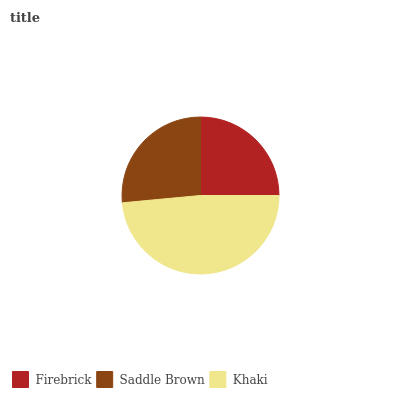Is Firebrick the minimum?
Answer yes or no. Yes. Is Khaki the maximum?
Answer yes or no. Yes. Is Saddle Brown the minimum?
Answer yes or no. No. Is Saddle Brown the maximum?
Answer yes or no. No. Is Saddle Brown greater than Firebrick?
Answer yes or no. Yes. Is Firebrick less than Saddle Brown?
Answer yes or no. Yes. Is Firebrick greater than Saddle Brown?
Answer yes or no. No. Is Saddle Brown less than Firebrick?
Answer yes or no. No. Is Saddle Brown the high median?
Answer yes or no. Yes. Is Saddle Brown the low median?
Answer yes or no. Yes. Is Khaki the high median?
Answer yes or no. No. Is Firebrick the low median?
Answer yes or no. No. 